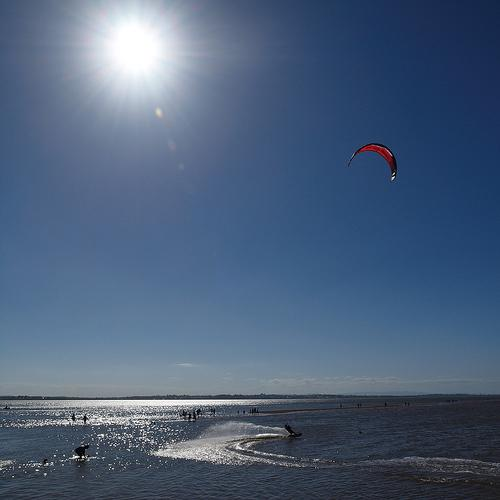List three different tasks that can be carried out with the information provided in the image. 3. Object interaction analysis task – examining how different elements in the image, like the sun, kite, and people, interact with each other. Provide a possible caption for the image that encompasses its main features. A scenic beach day with a sunlit blue sky, white clouds, a red kite, and people enjoying the water. What is the weather like in the picture? It's a sunny and clear day with some white clouds in the sky. Detail the environment where the people are and what they are doing. People are in the water at the beach, enjoying various activities such as swimming, standing in shallow water, and parasailing. What is the most prominent color in the sky, and what other hues are present? The sky is mostly blue, with some white clouds scattered throughout and a red kite. Mention features of the image's landscape and the overall sentiment. Beautiful beach scene with blue sky, sun, white clouds, and people in the water. The image evokes a positive and relaxing sentiment. Identify the main objects found in the sky portion of the image. Sun, red kite, and white clouds in the blue sky. What type of cloud formation is visible in the image? White clouds are scattered throughout the blue sky, adding visual interest without blocking the sun. Count the number of people mentioned in the image and describe what they are doing. There are at least six people in the water doing various activities, such as swimming, parasailing, and standing in shallow water. Analyze the interaction between the sun and the camera lens in the image. The sun's position in the sky caused a flare or glare on the camera lens, capturing sunrays and bright spots. 